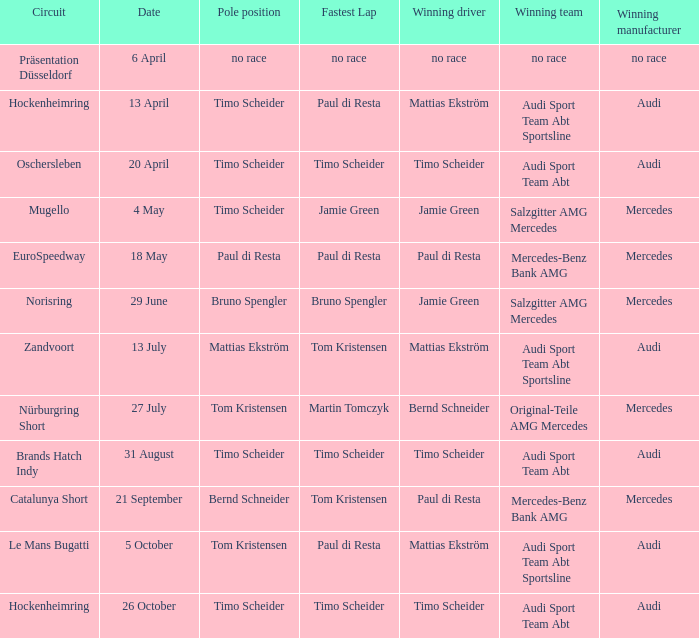What is the winning team of the race on 31 August with Audi as the winning manufacturer and Timo Scheider as the winning driver? Audi Sport Team Abt. 